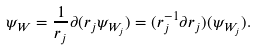Convert formula to latex. <formula><loc_0><loc_0><loc_500><loc_500>\psi _ { W } = \frac { 1 } { r _ { j } } \partial ( r _ { j } \psi _ { W _ { j } } ) = ( r ^ { - 1 } _ { j } \partial r _ { j } ) ( \psi _ { W _ { j } } ) .</formula> 